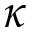<formula> <loc_0><loc_0><loc_500><loc_500>\kappa</formula> 